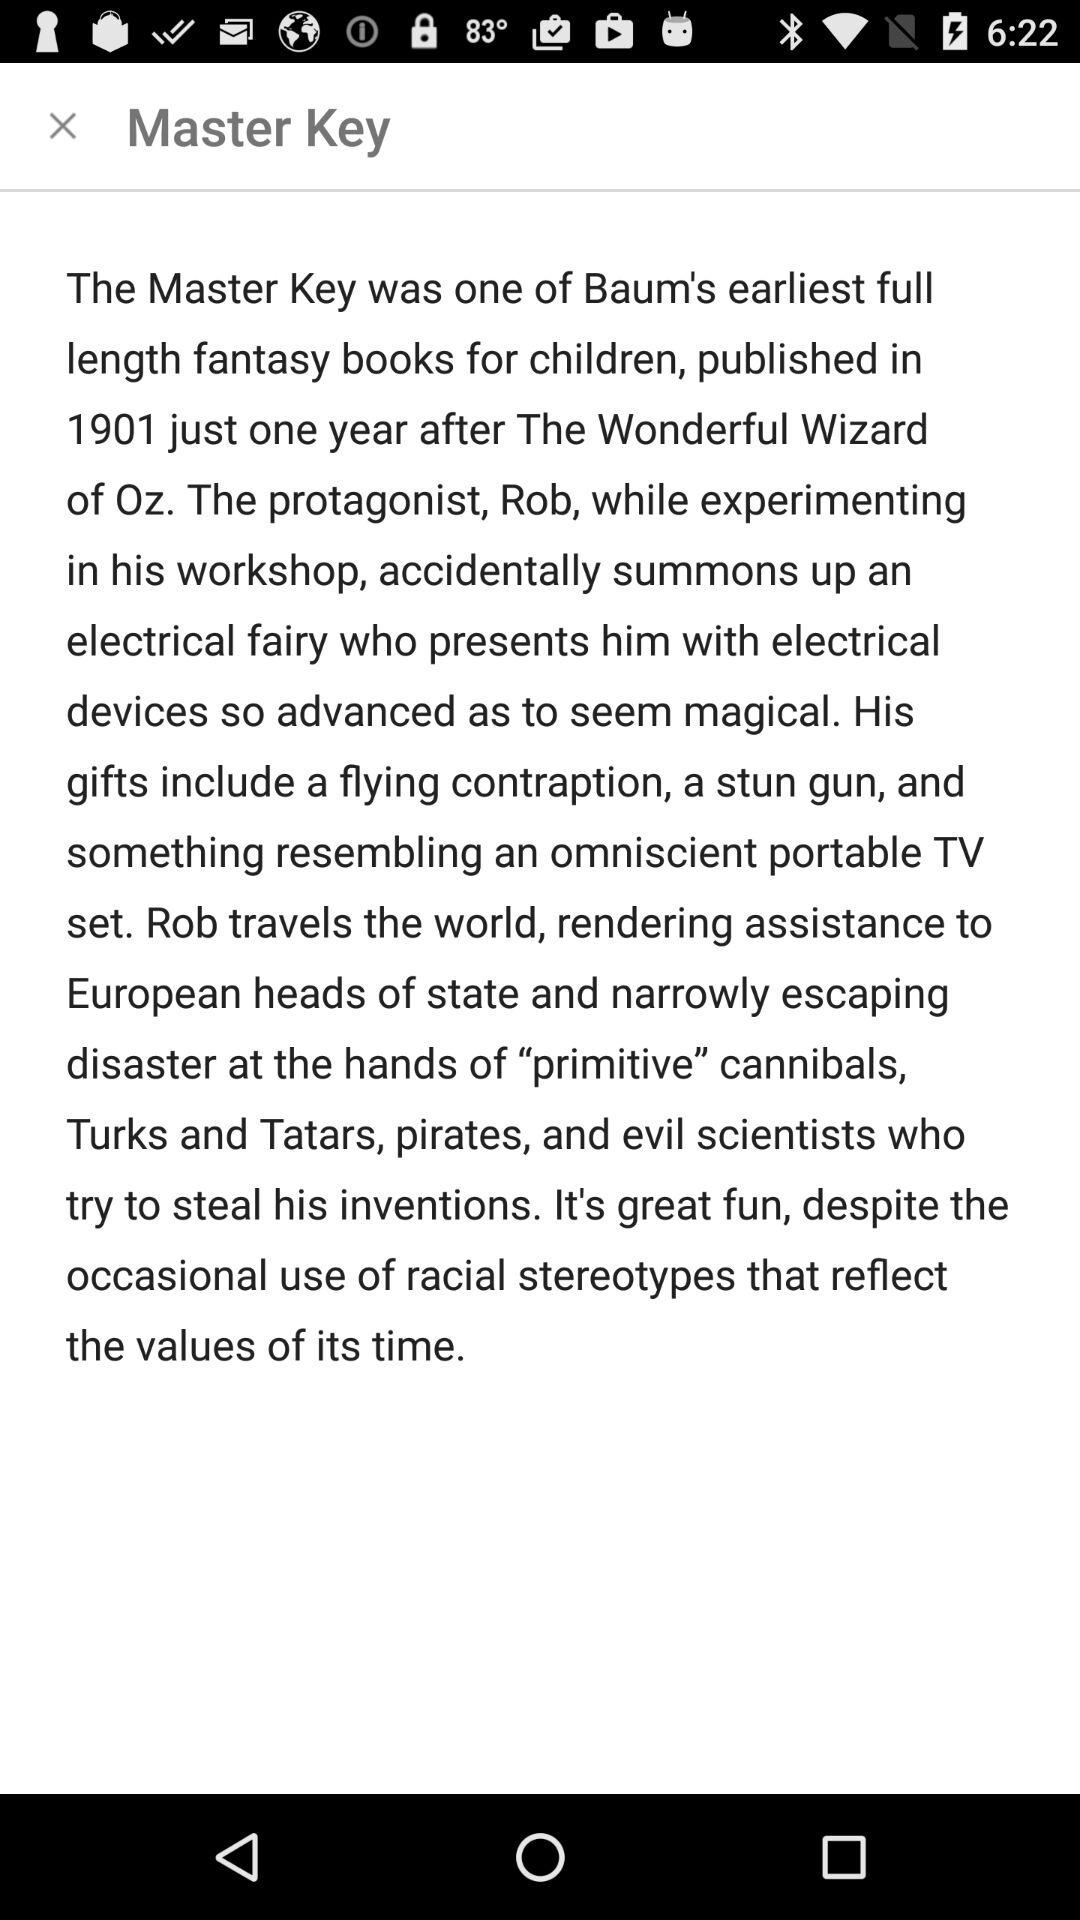When was the "Master Key" book published? The "Master Key" book was published in 1901. 